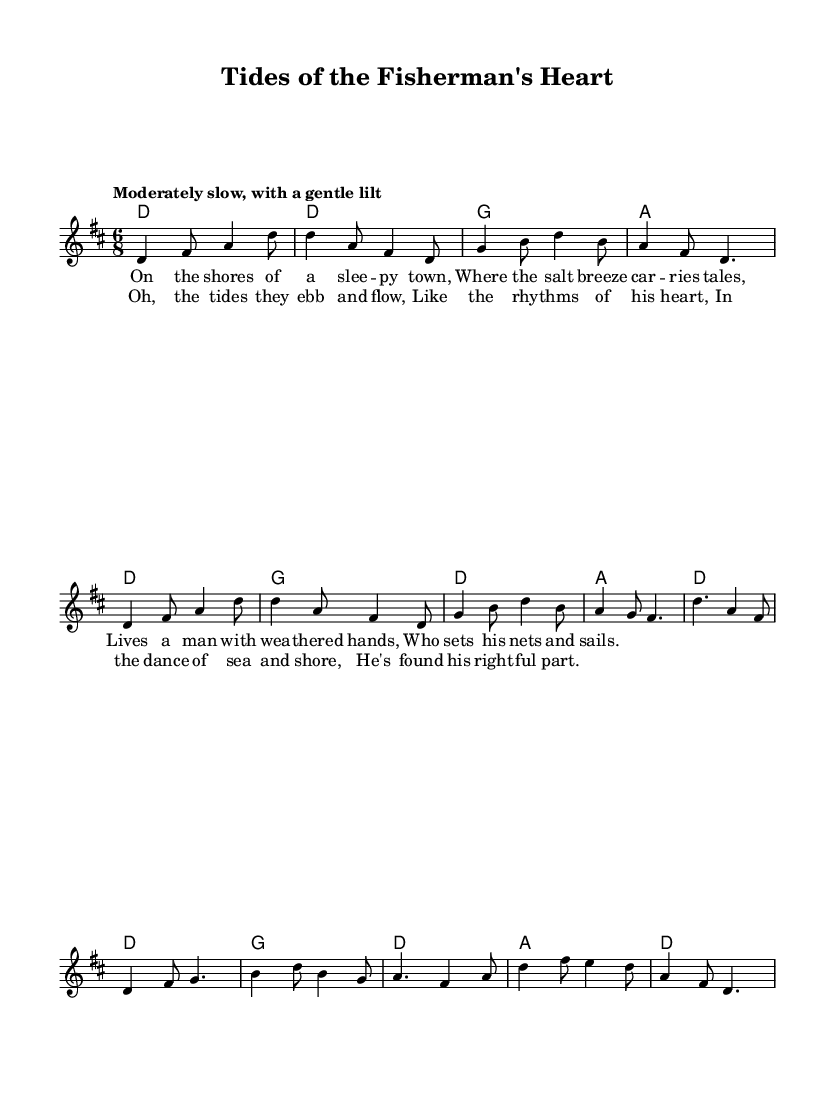What is the key signature of this music? The key signature is D major, which has two sharps (F# and C#). You can identify the key signature by looking at the sharps or flats at the beginning of the staff.
Answer: D major What is the time signature of this piece? The time signature is 6/8, which is indicated at the beginning of the staff. It suggests that there are six eighth notes in each measure, typically felt as two groups of three.
Answer: 6/8 What is the tempo marking for this music? The tempo marking is "Moderately slow, with a gentle lilt," which sets the general pacing and style for how the piece should be played. This directive is placed above the staff at the beginning of the score.
Answer: Moderately slow, with a gentle lilt How many measures are there in the chorus? The chorus consists of 6 measures, which can be counted by looking at the numbered bar lines from the start to the end of the chorus section.
Answer: 6 What unique elements of Folk music are represented in the lyrics? The lyrics include imagery of coastal life, such as "the shores of a sleepy town" and reference the daily life of fishermen, which is common in Folk music that reflects local culture and traditions.
Answer: Coastal life and fishermen What is the melodic range of the lead vocal part in this piece? The melodic range extends from D4 to B5, which can be determined by identifying the lowest and highest notes on the staff within the lead vocal line. This range gives insight into the vocal demands of the piece.
Answer: D4 to B5 